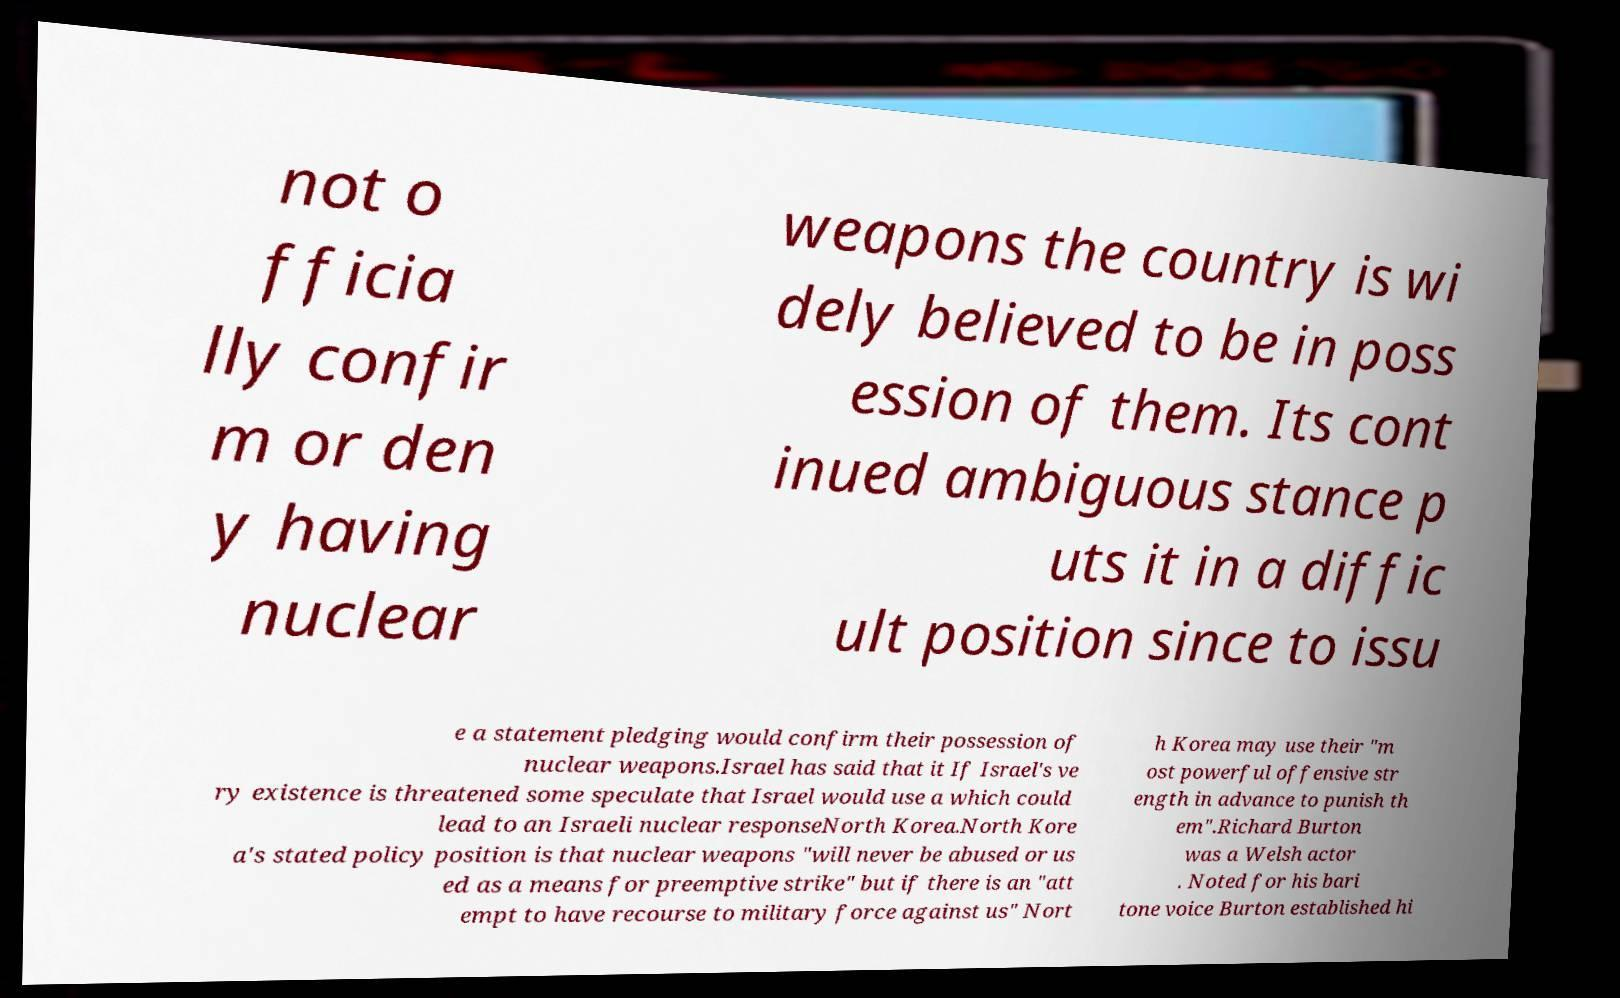What messages or text are displayed in this image? I need them in a readable, typed format. not o fficia lly confir m or den y having nuclear weapons the country is wi dely believed to be in poss ession of them. Its cont inued ambiguous stance p uts it in a diffic ult position since to issu e a statement pledging would confirm their possession of nuclear weapons.Israel has said that it If Israel's ve ry existence is threatened some speculate that Israel would use a which could lead to an Israeli nuclear responseNorth Korea.North Kore a's stated policy position is that nuclear weapons "will never be abused or us ed as a means for preemptive strike" but if there is an "att empt to have recourse to military force against us" Nort h Korea may use their "m ost powerful offensive str ength in advance to punish th em".Richard Burton was a Welsh actor . Noted for his bari tone voice Burton established hi 